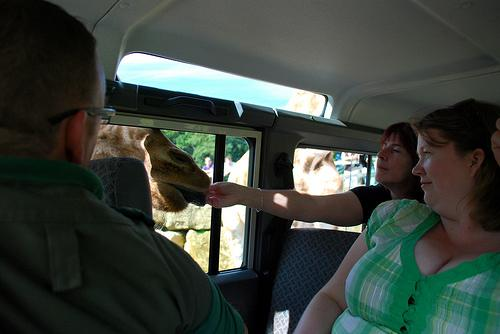In a simple sentence, tell me the main event occurring in the picture. A woman in a car is feeding a giraffe while a man observes. Write a one-sentence summary of the key happening in the picture. A woman, sitting inside a car with an open window, feeds a giraffe while a man beside her gazes in awe. Provide a brief overview of the primary focus in the image. A woman feeds a giraffe from her car as the man beside her watches. The car window is open, and the giraffe's snout is inside. Briefly describe the primary visual event occurring in the image. A woman in a green and white shirt feeds a giraffe from a car as a man wearing black eyeglasses observes the interaction. Write a short summary of the most prominent event unfolding in the image. A woman inside a car is passing food to a friendly giraffe, which has its head inside the window, as a man seated next to her observes. In one sentence, mention the weather and the central activity in the image. Under a cloudy blue sky, a woman inside a car feeds a giraffe through an open window as the man beside her looks on. Give a concise explanation of the primary action taking place between the main characters of the image. A giraffe is being fed by a woman through an open car window while a man sits inside the car, witnessing the interaction. Write a descriptive sentence that captures the essence of what is happening in the image.  In the photo, an intrigued man watches as a woman reaches out from an open car window to feed a curious giraffe poking its head inside. In a simple sentence, describe the main interaction happening in the picture. A giraffe sticking its head through a car window gets fed by a woman as a man watches. Describe the main event taking place in the image using an active voice. A woman feeds a playful giraffe from an opened car window, while an intrigued man watches the interaction. 